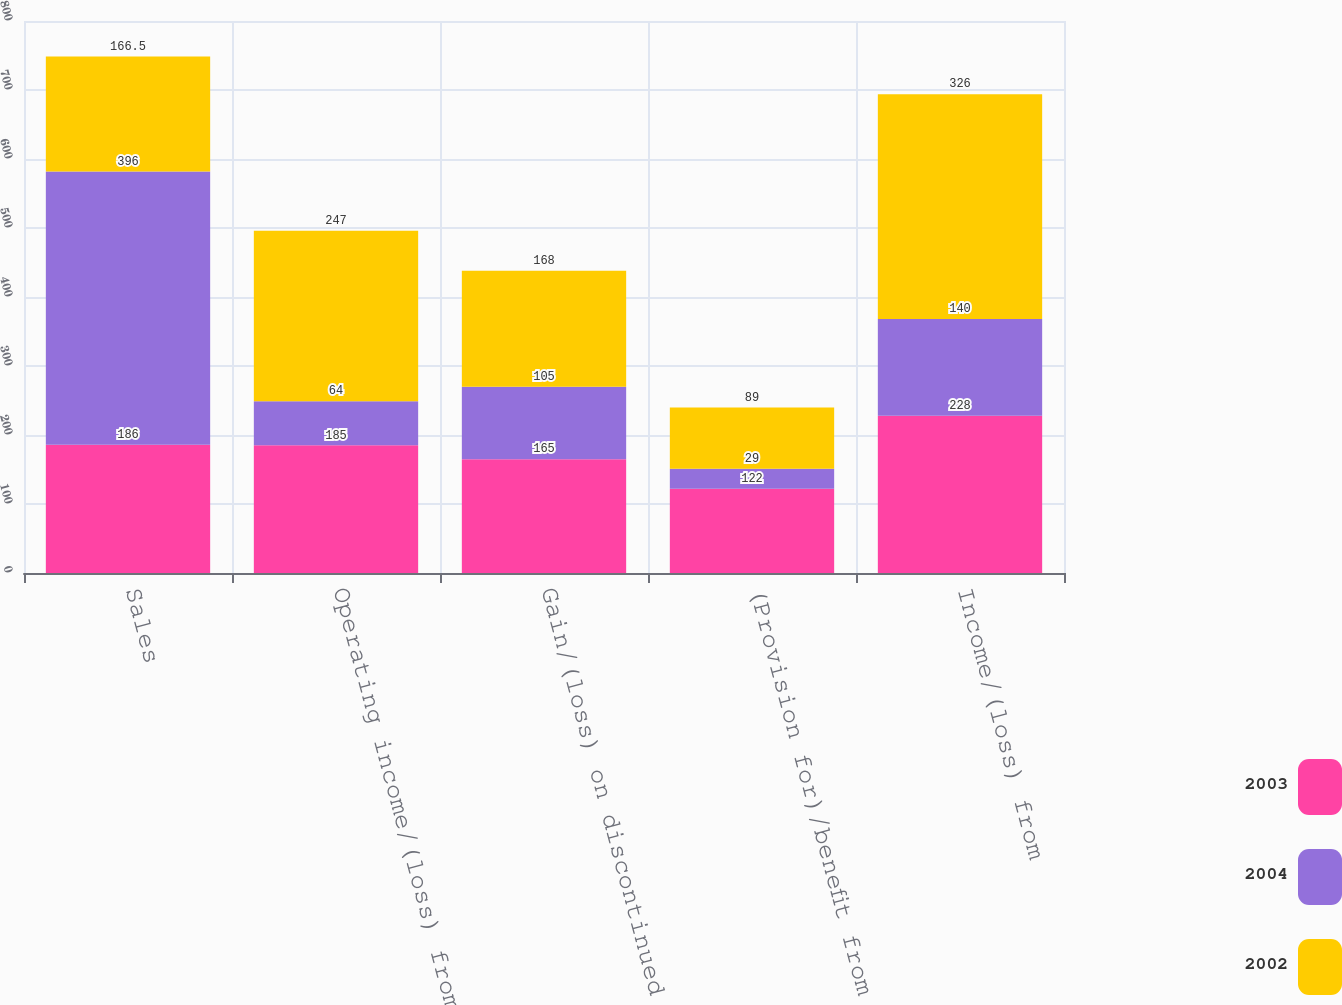Convert chart to OTSL. <chart><loc_0><loc_0><loc_500><loc_500><stacked_bar_chart><ecel><fcel>Sales<fcel>Operating income/(loss) from<fcel>Gain/(loss) on discontinued<fcel>(Provision for)/benefit from<fcel>Income/(loss) from<nl><fcel>2003<fcel>186<fcel>185<fcel>165<fcel>122<fcel>228<nl><fcel>2004<fcel>396<fcel>64<fcel>105<fcel>29<fcel>140<nl><fcel>2002<fcel>166.5<fcel>247<fcel>168<fcel>89<fcel>326<nl></chart> 